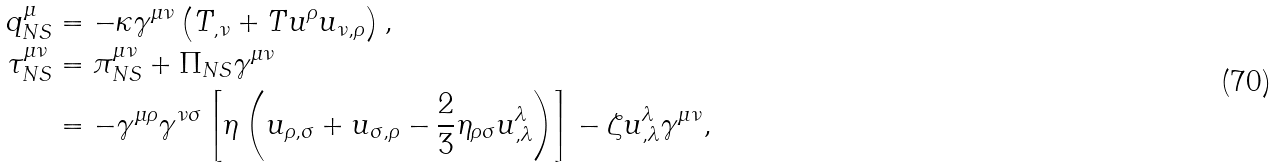Convert formula to latex. <formula><loc_0><loc_0><loc_500><loc_500>q _ { N S } ^ { \mu } & = - \kappa \gamma ^ { \mu \nu } \left ( T _ { , \nu } + T u ^ { \rho } u _ { \nu , \rho } \right ) , \\ \tau _ { N S } ^ { \mu \nu } & = \pi ^ { \mu \nu } _ { N S } + \Pi _ { N S } \gamma ^ { \mu \nu } \\ & = - \gamma ^ { \mu \rho } \gamma ^ { \nu \sigma } \left [ \eta \left ( u _ { \rho , \sigma } + u _ { \sigma , \rho } - \frac { 2 } { 3 } \eta _ { \rho \sigma } u ^ { \lambda } _ { , \lambda } \right ) \right ] - \zeta u ^ { \lambda } _ { , \lambda } \gamma ^ { \mu \nu } ,</formula> 